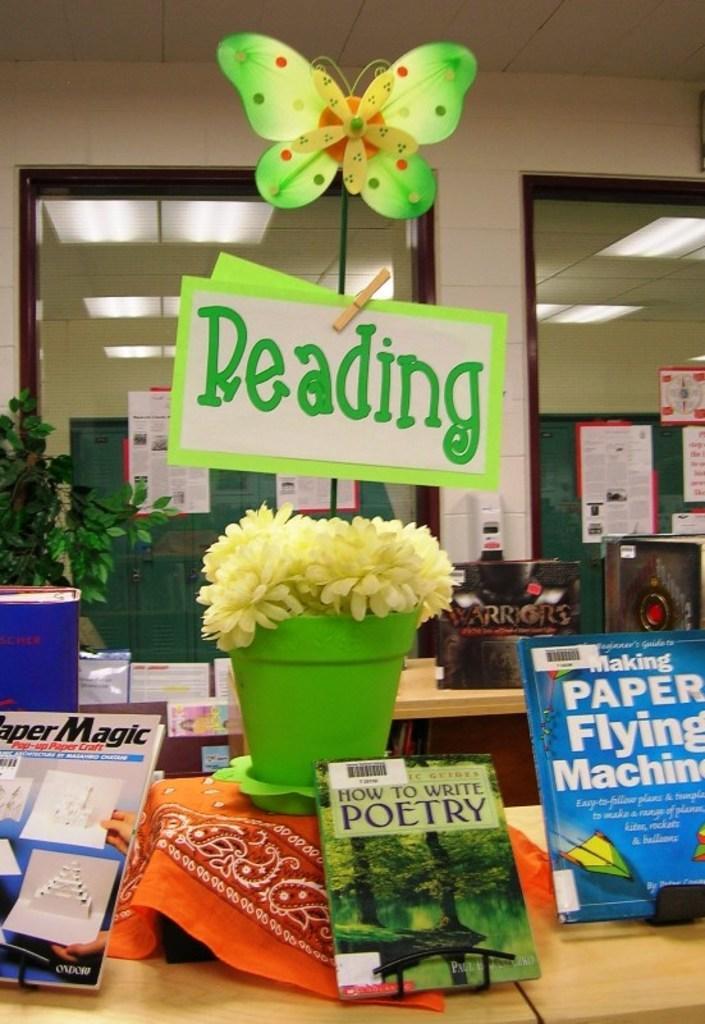In one or two sentences, can you explain what this image depicts? At the bottom of this image there are few tables on which books, flower pot, a cloth, boxes and some other objects are placed. In the background there is a wall and many posters are attached to the glasses. On the left side few leaves are visible. In the middle of the image there is a board with some text and an artificial butterfly are attached to a stick. In the background there are few lights to the ceiling. 